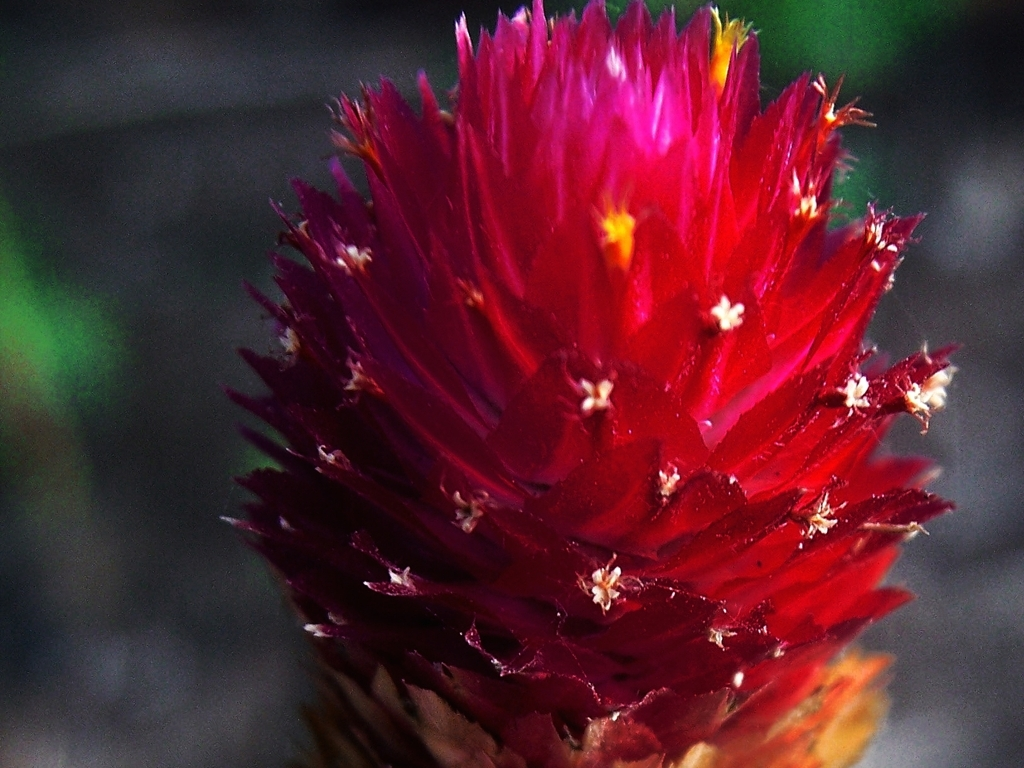What is the color quality like in the image?
A. Dull
B. Lack of color
C. Rich
D. Faded
Answer with the option's letter from the given choices directly.
 C. 